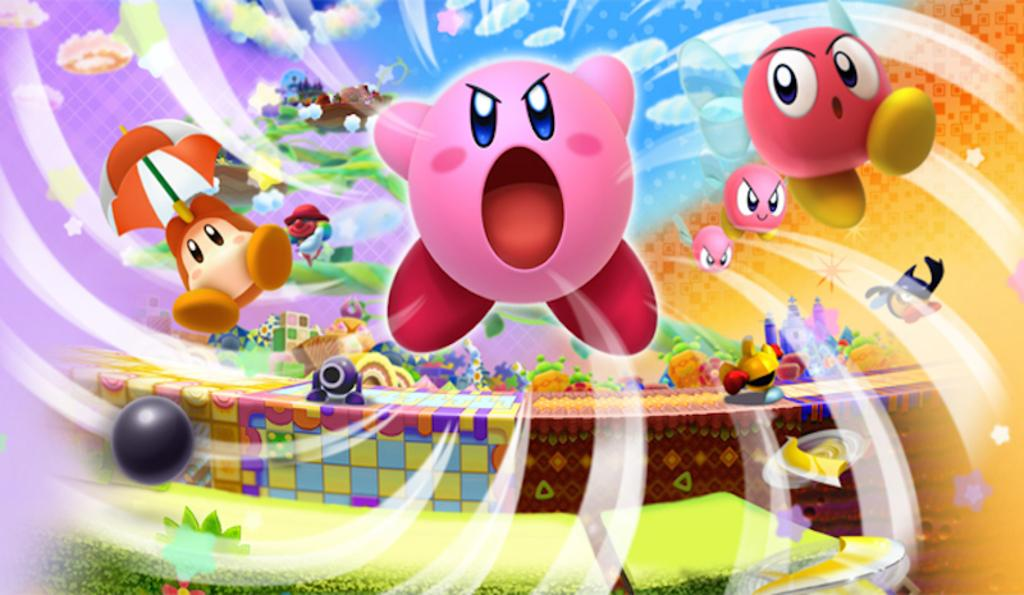What type of objects can be seen in the image? There are toys, an umbrella, a ball, and some unspecified objects in the image. What is the condition of the sky in the image? The sky is visible in the image, and it has clouds. Can you describe the umbrella in the image? The umbrella is one of the objects visible in the image. What type of news can be heard coming from the station in the image? There is no station or news present in the image; it features toys, an umbrella, a ball, and some unspecified objects with a cloudy sky. 